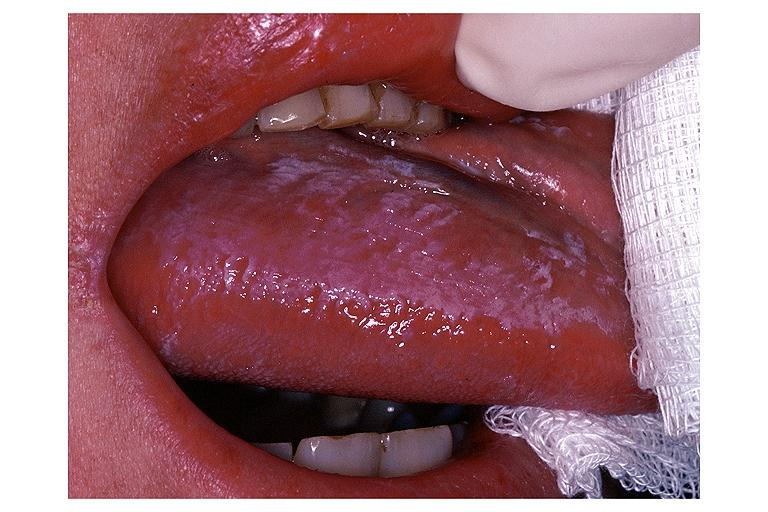s vessel present?
Answer the question using a single word or phrase. No 